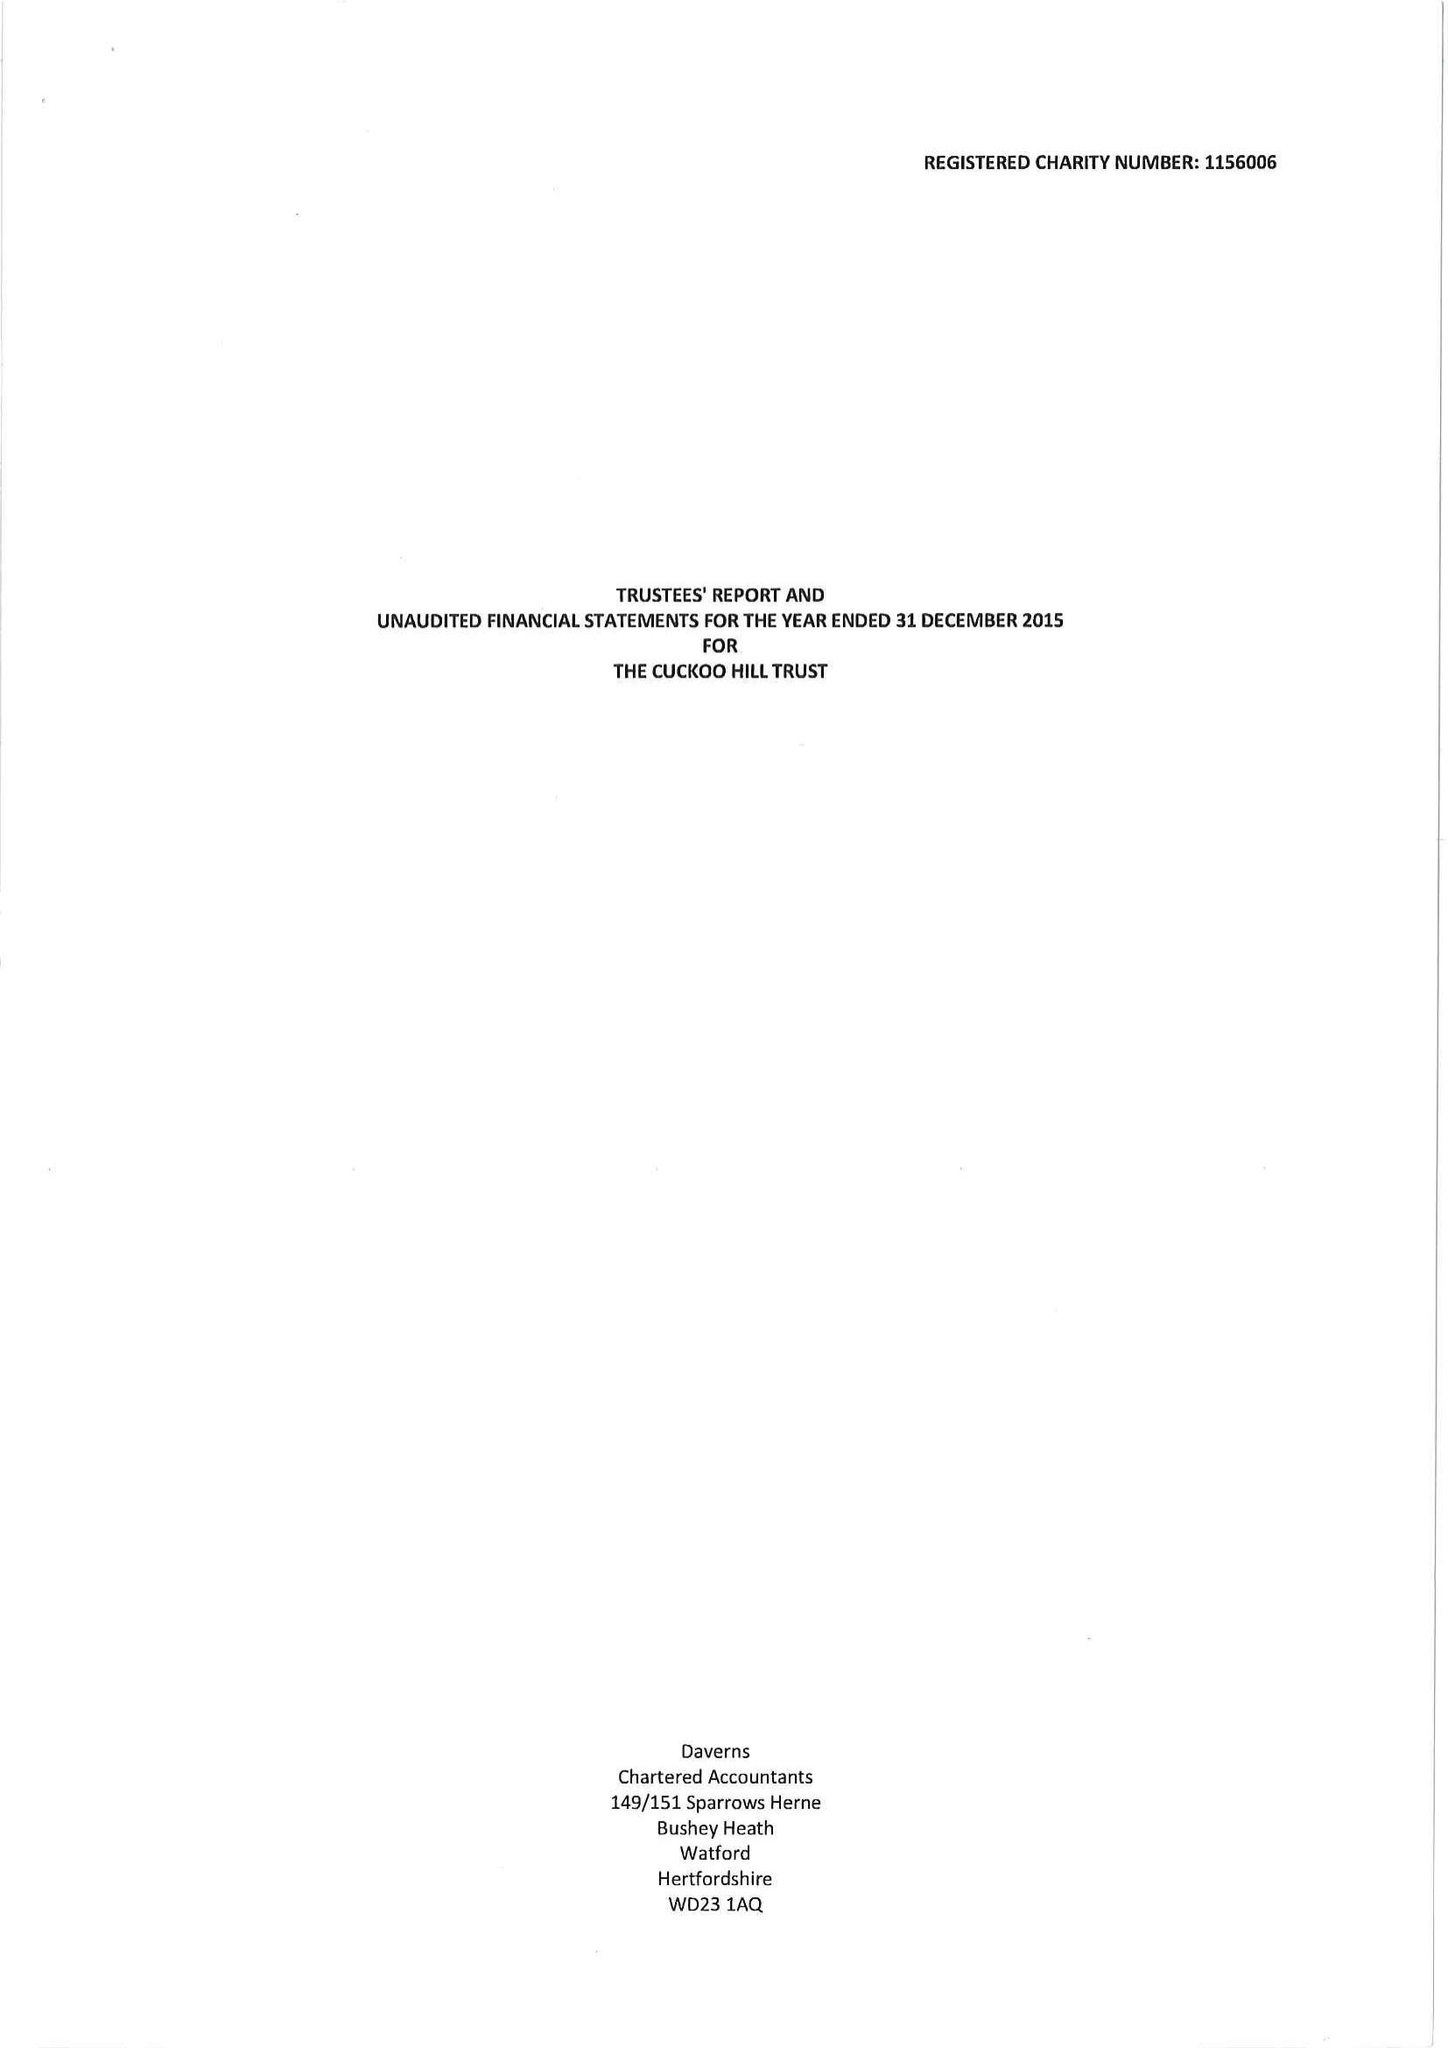What is the value for the address__postcode?
Answer the question using a single word or phrase. HA5 2BB 